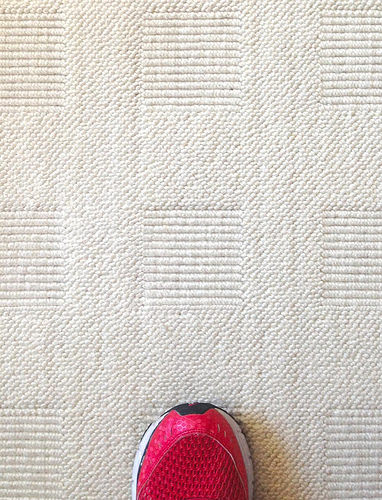<image>
Is there a shoe in the cloth? No. The shoe is not contained within the cloth. These objects have a different spatial relationship. 